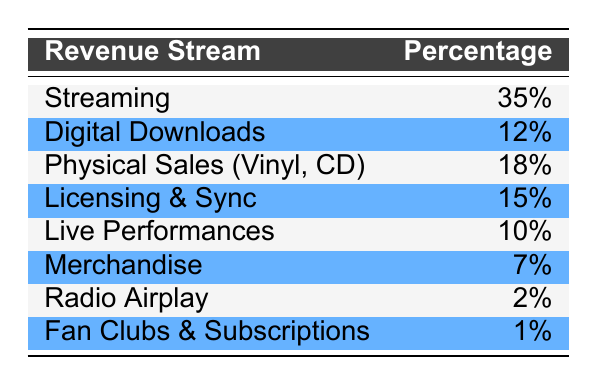What is the revenue percentage from streaming? The table lists streaming revenue at 35%.
Answer: 35% Which revenue stream has the lowest percentage? Fan clubs and subscriptions have the lowest percentage at 1%.
Answer: 1% What is the total percentage of revenue from physical sales (vinyl, CD) and digital downloads? The percentage for physical sales is 18%, and for digital downloads, it is 12%. Adding these gives 18 + 12 = 30.
Answer: 30% Is the revenue from live performances greater than that from merchandise? Live performances generate 10% while merchandise generates 7%. Since 10 is greater than 7, the statement is true.
Answer: Yes What percentage of the total revenue comes from licensing and sync compared to live performances? Licensing and sync accounts for 15% while live performances account for 10%. 15% is greater than 10%.
Answer: 15% is greater than 10% What is the combined revenue percentage from streaming and live performances? Streaming accounts for 35% and live performances account for 10%. Adding these gives 35 + 10 = 45.
Answer: 45% Is the total revenue from all sources equal to 100%? Each percentage in the table contributes to the total, which sums up to 100%.
Answer: Yes What is the difference in revenue percentage between physical sales and radio airplay? Physical sales are at 18% and radio airplay is at 2%. The difference is 18 - 2 = 16.
Answer: 16% What would be the percentage of revenue from merchandise if it doubled? Merchandise is currently at 7%, doubling it would give 7 * 2 = 14.
Answer: 14% 